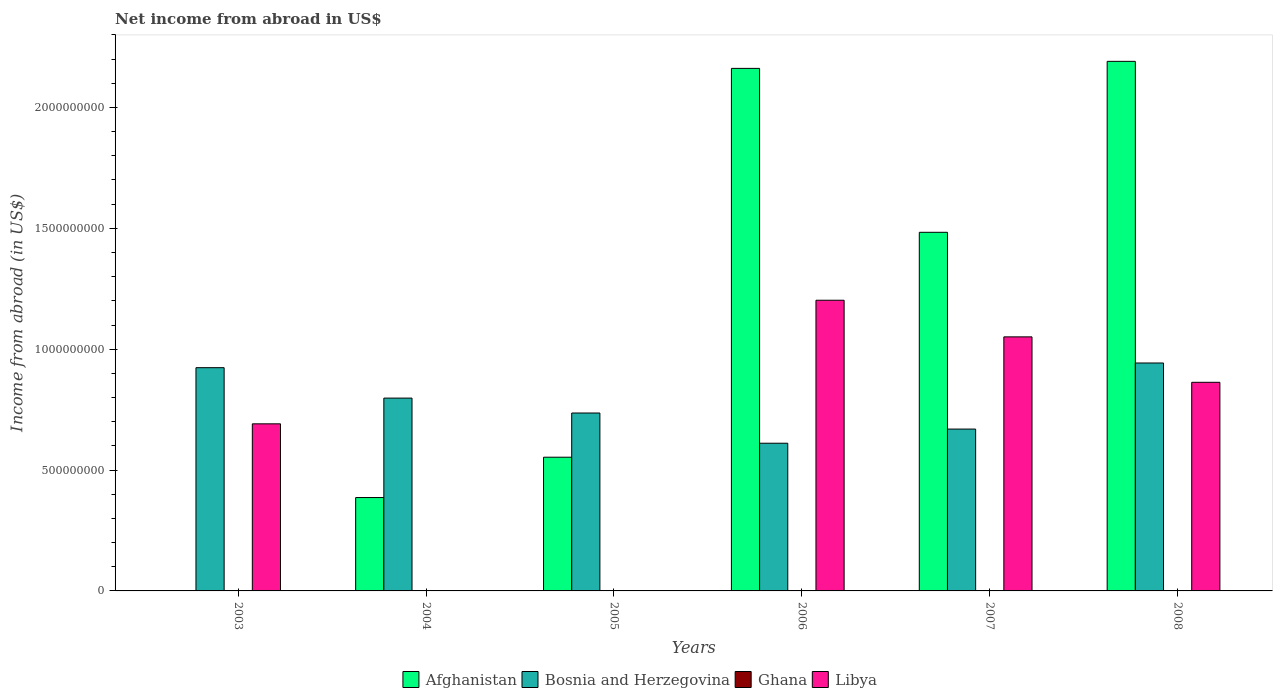What is the label of the 4th group of bars from the left?
Make the answer very short. 2006. What is the net income from abroad in Bosnia and Herzegovina in 2004?
Make the answer very short. 7.98e+08. Across all years, what is the maximum net income from abroad in Libya?
Your answer should be very brief. 1.20e+09. What is the difference between the net income from abroad in Afghanistan in 2004 and that in 2007?
Your answer should be very brief. -1.10e+09. What is the difference between the net income from abroad in Libya in 2006 and the net income from abroad in Bosnia and Herzegovina in 2004?
Offer a terse response. 4.05e+08. In the year 2008, what is the difference between the net income from abroad in Libya and net income from abroad in Afghanistan?
Your answer should be compact. -1.33e+09. What is the ratio of the net income from abroad in Afghanistan in 2005 to that in 2006?
Keep it short and to the point. 0.26. Is the net income from abroad in Afghanistan in 2006 less than that in 2008?
Your response must be concise. Yes. Is the difference between the net income from abroad in Libya in 2007 and 2008 greater than the difference between the net income from abroad in Afghanistan in 2007 and 2008?
Make the answer very short. Yes. What is the difference between the highest and the second highest net income from abroad in Libya?
Make the answer very short. 1.52e+08. What is the difference between the highest and the lowest net income from abroad in Libya?
Your answer should be very brief. 1.20e+09. Is it the case that in every year, the sum of the net income from abroad in Bosnia and Herzegovina and net income from abroad in Libya is greater than the net income from abroad in Ghana?
Offer a very short reply. Yes. Does the graph contain grids?
Your answer should be very brief. No. Where does the legend appear in the graph?
Offer a terse response. Bottom center. What is the title of the graph?
Your answer should be compact. Net income from abroad in US$. Does "Europe(developing only)" appear as one of the legend labels in the graph?
Offer a terse response. No. What is the label or title of the Y-axis?
Make the answer very short. Income from abroad (in US$). What is the Income from abroad (in US$) in Afghanistan in 2003?
Offer a terse response. 0. What is the Income from abroad (in US$) of Bosnia and Herzegovina in 2003?
Ensure brevity in your answer.  9.24e+08. What is the Income from abroad (in US$) in Ghana in 2003?
Your answer should be compact. 0. What is the Income from abroad (in US$) in Libya in 2003?
Keep it short and to the point. 6.91e+08. What is the Income from abroad (in US$) of Afghanistan in 2004?
Provide a succinct answer. 3.86e+08. What is the Income from abroad (in US$) of Bosnia and Herzegovina in 2004?
Your answer should be very brief. 7.98e+08. What is the Income from abroad (in US$) in Ghana in 2004?
Your answer should be compact. 0. What is the Income from abroad (in US$) in Libya in 2004?
Make the answer very short. 0. What is the Income from abroad (in US$) in Afghanistan in 2005?
Provide a short and direct response. 5.53e+08. What is the Income from abroad (in US$) in Bosnia and Herzegovina in 2005?
Ensure brevity in your answer.  7.36e+08. What is the Income from abroad (in US$) in Afghanistan in 2006?
Provide a succinct answer. 2.16e+09. What is the Income from abroad (in US$) in Bosnia and Herzegovina in 2006?
Your answer should be very brief. 6.11e+08. What is the Income from abroad (in US$) of Ghana in 2006?
Provide a short and direct response. 0. What is the Income from abroad (in US$) in Libya in 2006?
Your answer should be very brief. 1.20e+09. What is the Income from abroad (in US$) in Afghanistan in 2007?
Offer a very short reply. 1.48e+09. What is the Income from abroad (in US$) of Bosnia and Herzegovina in 2007?
Your answer should be very brief. 6.70e+08. What is the Income from abroad (in US$) of Ghana in 2007?
Offer a very short reply. 0. What is the Income from abroad (in US$) of Libya in 2007?
Your answer should be very brief. 1.05e+09. What is the Income from abroad (in US$) of Afghanistan in 2008?
Provide a short and direct response. 2.19e+09. What is the Income from abroad (in US$) of Bosnia and Herzegovina in 2008?
Provide a succinct answer. 9.43e+08. What is the Income from abroad (in US$) of Libya in 2008?
Make the answer very short. 8.63e+08. Across all years, what is the maximum Income from abroad (in US$) of Afghanistan?
Your answer should be compact. 2.19e+09. Across all years, what is the maximum Income from abroad (in US$) of Bosnia and Herzegovina?
Offer a very short reply. 9.43e+08. Across all years, what is the maximum Income from abroad (in US$) in Libya?
Provide a short and direct response. 1.20e+09. Across all years, what is the minimum Income from abroad (in US$) in Afghanistan?
Your answer should be very brief. 0. Across all years, what is the minimum Income from abroad (in US$) of Bosnia and Herzegovina?
Provide a succinct answer. 6.11e+08. What is the total Income from abroad (in US$) of Afghanistan in the graph?
Provide a short and direct response. 6.78e+09. What is the total Income from abroad (in US$) of Bosnia and Herzegovina in the graph?
Your answer should be compact. 4.68e+09. What is the total Income from abroad (in US$) in Ghana in the graph?
Provide a short and direct response. 0. What is the total Income from abroad (in US$) in Libya in the graph?
Your answer should be compact. 3.81e+09. What is the difference between the Income from abroad (in US$) in Bosnia and Herzegovina in 2003 and that in 2004?
Make the answer very short. 1.26e+08. What is the difference between the Income from abroad (in US$) in Bosnia and Herzegovina in 2003 and that in 2005?
Provide a succinct answer. 1.88e+08. What is the difference between the Income from abroad (in US$) of Bosnia and Herzegovina in 2003 and that in 2006?
Offer a very short reply. 3.13e+08. What is the difference between the Income from abroad (in US$) of Libya in 2003 and that in 2006?
Give a very brief answer. -5.11e+08. What is the difference between the Income from abroad (in US$) of Bosnia and Herzegovina in 2003 and that in 2007?
Give a very brief answer. 2.54e+08. What is the difference between the Income from abroad (in US$) in Libya in 2003 and that in 2007?
Make the answer very short. -3.60e+08. What is the difference between the Income from abroad (in US$) of Bosnia and Herzegovina in 2003 and that in 2008?
Offer a terse response. -1.94e+07. What is the difference between the Income from abroad (in US$) in Libya in 2003 and that in 2008?
Ensure brevity in your answer.  -1.72e+08. What is the difference between the Income from abroad (in US$) in Afghanistan in 2004 and that in 2005?
Your answer should be very brief. -1.67e+08. What is the difference between the Income from abroad (in US$) of Bosnia and Herzegovina in 2004 and that in 2005?
Offer a terse response. 6.17e+07. What is the difference between the Income from abroad (in US$) of Afghanistan in 2004 and that in 2006?
Make the answer very short. -1.78e+09. What is the difference between the Income from abroad (in US$) in Bosnia and Herzegovina in 2004 and that in 2006?
Give a very brief answer. 1.87e+08. What is the difference between the Income from abroad (in US$) in Afghanistan in 2004 and that in 2007?
Your answer should be compact. -1.10e+09. What is the difference between the Income from abroad (in US$) in Bosnia and Herzegovina in 2004 and that in 2007?
Provide a succinct answer. 1.28e+08. What is the difference between the Income from abroad (in US$) of Afghanistan in 2004 and that in 2008?
Give a very brief answer. -1.80e+09. What is the difference between the Income from abroad (in US$) in Bosnia and Herzegovina in 2004 and that in 2008?
Offer a terse response. -1.45e+08. What is the difference between the Income from abroad (in US$) in Afghanistan in 2005 and that in 2006?
Ensure brevity in your answer.  -1.61e+09. What is the difference between the Income from abroad (in US$) of Bosnia and Herzegovina in 2005 and that in 2006?
Your response must be concise. 1.25e+08. What is the difference between the Income from abroad (in US$) of Afghanistan in 2005 and that in 2007?
Your answer should be very brief. -9.30e+08. What is the difference between the Income from abroad (in US$) of Bosnia and Herzegovina in 2005 and that in 2007?
Your answer should be compact. 6.64e+07. What is the difference between the Income from abroad (in US$) of Afghanistan in 2005 and that in 2008?
Provide a short and direct response. -1.64e+09. What is the difference between the Income from abroad (in US$) in Bosnia and Herzegovina in 2005 and that in 2008?
Offer a very short reply. -2.07e+08. What is the difference between the Income from abroad (in US$) in Afghanistan in 2006 and that in 2007?
Keep it short and to the point. 6.78e+08. What is the difference between the Income from abroad (in US$) in Bosnia and Herzegovina in 2006 and that in 2007?
Offer a terse response. -5.86e+07. What is the difference between the Income from abroad (in US$) in Libya in 2006 and that in 2007?
Keep it short and to the point. 1.52e+08. What is the difference between the Income from abroad (in US$) in Afghanistan in 2006 and that in 2008?
Provide a succinct answer. -2.91e+07. What is the difference between the Income from abroad (in US$) of Bosnia and Herzegovina in 2006 and that in 2008?
Make the answer very short. -3.32e+08. What is the difference between the Income from abroad (in US$) in Libya in 2006 and that in 2008?
Your response must be concise. 3.40e+08. What is the difference between the Income from abroad (in US$) of Afghanistan in 2007 and that in 2008?
Offer a very short reply. -7.07e+08. What is the difference between the Income from abroad (in US$) in Bosnia and Herzegovina in 2007 and that in 2008?
Provide a short and direct response. -2.73e+08. What is the difference between the Income from abroad (in US$) of Libya in 2007 and that in 2008?
Provide a short and direct response. 1.88e+08. What is the difference between the Income from abroad (in US$) of Bosnia and Herzegovina in 2003 and the Income from abroad (in US$) of Libya in 2006?
Give a very brief answer. -2.79e+08. What is the difference between the Income from abroad (in US$) of Bosnia and Herzegovina in 2003 and the Income from abroad (in US$) of Libya in 2007?
Make the answer very short. -1.27e+08. What is the difference between the Income from abroad (in US$) of Bosnia and Herzegovina in 2003 and the Income from abroad (in US$) of Libya in 2008?
Offer a terse response. 6.05e+07. What is the difference between the Income from abroad (in US$) of Afghanistan in 2004 and the Income from abroad (in US$) of Bosnia and Herzegovina in 2005?
Provide a short and direct response. -3.50e+08. What is the difference between the Income from abroad (in US$) of Afghanistan in 2004 and the Income from abroad (in US$) of Bosnia and Herzegovina in 2006?
Give a very brief answer. -2.25e+08. What is the difference between the Income from abroad (in US$) of Afghanistan in 2004 and the Income from abroad (in US$) of Libya in 2006?
Your answer should be compact. -8.16e+08. What is the difference between the Income from abroad (in US$) in Bosnia and Herzegovina in 2004 and the Income from abroad (in US$) in Libya in 2006?
Keep it short and to the point. -4.05e+08. What is the difference between the Income from abroad (in US$) in Afghanistan in 2004 and the Income from abroad (in US$) in Bosnia and Herzegovina in 2007?
Offer a terse response. -2.83e+08. What is the difference between the Income from abroad (in US$) of Afghanistan in 2004 and the Income from abroad (in US$) of Libya in 2007?
Keep it short and to the point. -6.65e+08. What is the difference between the Income from abroad (in US$) in Bosnia and Herzegovina in 2004 and the Income from abroad (in US$) in Libya in 2007?
Keep it short and to the point. -2.53e+08. What is the difference between the Income from abroad (in US$) in Afghanistan in 2004 and the Income from abroad (in US$) in Bosnia and Herzegovina in 2008?
Make the answer very short. -5.57e+08. What is the difference between the Income from abroad (in US$) in Afghanistan in 2004 and the Income from abroad (in US$) in Libya in 2008?
Offer a very short reply. -4.77e+08. What is the difference between the Income from abroad (in US$) in Bosnia and Herzegovina in 2004 and the Income from abroad (in US$) in Libya in 2008?
Offer a terse response. -6.53e+07. What is the difference between the Income from abroad (in US$) of Afghanistan in 2005 and the Income from abroad (in US$) of Bosnia and Herzegovina in 2006?
Ensure brevity in your answer.  -5.79e+07. What is the difference between the Income from abroad (in US$) of Afghanistan in 2005 and the Income from abroad (in US$) of Libya in 2006?
Provide a short and direct response. -6.49e+08. What is the difference between the Income from abroad (in US$) of Bosnia and Herzegovina in 2005 and the Income from abroad (in US$) of Libya in 2006?
Ensure brevity in your answer.  -4.66e+08. What is the difference between the Income from abroad (in US$) in Afghanistan in 2005 and the Income from abroad (in US$) in Bosnia and Herzegovina in 2007?
Your answer should be compact. -1.16e+08. What is the difference between the Income from abroad (in US$) of Afghanistan in 2005 and the Income from abroad (in US$) of Libya in 2007?
Provide a succinct answer. -4.98e+08. What is the difference between the Income from abroad (in US$) in Bosnia and Herzegovina in 2005 and the Income from abroad (in US$) in Libya in 2007?
Give a very brief answer. -3.15e+08. What is the difference between the Income from abroad (in US$) in Afghanistan in 2005 and the Income from abroad (in US$) in Bosnia and Herzegovina in 2008?
Keep it short and to the point. -3.90e+08. What is the difference between the Income from abroad (in US$) of Afghanistan in 2005 and the Income from abroad (in US$) of Libya in 2008?
Provide a succinct answer. -3.10e+08. What is the difference between the Income from abroad (in US$) of Bosnia and Herzegovina in 2005 and the Income from abroad (in US$) of Libya in 2008?
Provide a short and direct response. -1.27e+08. What is the difference between the Income from abroad (in US$) of Afghanistan in 2006 and the Income from abroad (in US$) of Bosnia and Herzegovina in 2007?
Provide a short and direct response. 1.49e+09. What is the difference between the Income from abroad (in US$) of Afghanistan in 2006 and the Income from abroad (in US$) of Libya in 2007?
Keep it short and to the point. 1.11e+09. What is the difference between the Income from abroad (in US$) of Bosnia and Herzegovina in 2006 and the Income from abroad (in US$) of Libya in 2007?
Ensure brevity in your answer.  -4.40e+08. What is the difference between the Income from abroad (in US$) in Afghanistan in 2006 and the Income from abroad (in US$) in Bosnia and Herzegovina in 2008?
Offer a terse response. 1.22e+09. What is the difference between the Income from abroad (in US$) of Afghanistan in 2006 and the Income from abroad (in US$) of Libya in 2008?
Ensure brevity in your answer.  1.30e+09. What is the difference between the Income from abroad (in US$) in Bosnia and Herzegovina in 2006 and the Income from abroad (in US$) in Libya in 2008?
Offer a very short reply. -2.52e+08. What is the difference between the Income from abroad (in US$) in Afghanistan in 2007 and the Income from abroad (in US$) in Bosnia and Herzegovina in 2008?
Keep it short and to the point. 5.41e+08. What is the difference between the Income from abroad (in US$) of Afghanistan in 2007 and the Income from abroad (in US$) of Libya in 2008?
Give a very brief answer. 6.21e+08. What is the difference between the Income from abroad (in US$) in Bosnia and Herzegovina in 2007 and the Income from abroad (in US$) in Libya in 2008?
Provide a short and direct response. -1.93e+08. What is the average Income from abroad (in US$) in Afghanistan per year?
Give a very brief answer. 1.13e+09. What is the average Income from abroad (in US$) of Bosnia and Herzegovina per year?
Keep it short and to the point. 7.80e+08. What is the average Income from abroad (in US$) of Ghana per year?
Offer a terse response. 0. What is the average Income from abroad (in US$) in Libya per year?
Ensure brevity in your answer.  6.35e+08. In the year 2003, what is the difference between the Income from abroad (in US$) in Bosnia and Herzegovina and Income from abroad (in US$) in Libya?
Give a very brief answer. 2.32e+08. In the year 2004, what is the difference between the Income from abroad (in US$) of Afghanistan and Income from abroad (in US$) of Bosnia and Herzegovina?
Offer a very short reply. -4.11e+08. In the year 2005, what is the difference between the Income from abroad (in US$) in Afghanistan and Income from abroad (in US$) in Bosnia and Herzegovina?
Your answer should be compact. -1.83e+08. In the year 2006, what is the difference between the Income from abroad (in US$) of Afghanistan and Income from abroad (in US$) of Bosnia and Herzegovina?
Provide a succinct answer. 1.55e+09. In the year 2006, what is the difference between the Income from abroad (in US$) of Afghanistan and Income from abroad (in US$) of Libya?
Give a very brief answer. 9.59e+08. In the year 2006, what is the difference between the Income from abroad (in US$) in Bosnia and Herzegovina and Income from abroad (in US$) in Libya?
Make the answer very short. -5.92e+08. In the year 2007, what is the difference between the Income from abroad (in US$) of Afghanistan and Income from abroad (in US$) of Bosnia and Herzegovina?
Offer a terse response. 8.14e+08. In the year 2007, what is the difference between the Income from abroad (in US$) in Afghanistan and Income from abroad (in US$) in Libya?
Provide a succinct answer. 4.33e+08. In the year 2007, what is the difference between the Income from abroad (in US$) in Bosnia and Herzegovina and Income from abroad (in US$) in Libya?
Keep it short and to the point. -3.81e+08. In the year 2008, what is the difference between the Income from abroad (in US$) in Afghanistan and Income from abroad (in US$) in Bosnia and Herzegovina?
Give a very brief answer. 1.25e+09. In the year 2008, what is the difference between the Income from abroad (in US$) in Afghanistan and Income from abroad (in US$) in Libya?
Make the answer very short. 1.33e+09. In the year 2008, what is the difference between the Income from abroad (in US$) in Bosnia and Herzegovina and Income from abroad (in US$) in Libya?
Your answer should be compact. 7.99e+07. What is the ratio of the Income from abroad (in US$) of Bosnia and Herzegovina in 2003 to that in 2004?
Offer a terse response. 1.16. What is the ratio of the Income from abroad (in US$) of Bosnia and Herzegovina in 2003 to that in 2005?
Your answer should be compact. 1.25. What is the ratio of the Income from abroad (in US$) of Bosnia and Herzegovina in 2003 to that in 2006?
Provide a succinct answer. 1.51. What is the ratio of the Income from abroad (in US$) of Libya in 2003 to that in 2006?
Offer a very short reply. 0.57. What is the ratio of the Income from abroad (in US$) of Bosnia and Herzegovina in 2003 to that in 2007?
Offer a very short reply. 1.38. What is the ratio of the Income from abroad (in US$) of Libya in 2003 to that in 2007?
Offer a very short reply. 0.66. What is the ratio of the Income from abroad (in US$) of Bosnia and Herzegovina in 2003 to that in 2008?
Your answer should be very brief. 0.98. What is the ratio of the Income from abroad (in US$) in Libya in 2003 to that in 2008?
Ensure brevity in your answer.  0.8. What is the ratio of the Income from abroad (in US$) in Afghanistan in 2004 to that in 2005?
Provide a short and direct response. 0.7. What is the ratio of the Income from abroad (in US$) in Bosnia and Herzegovina in 2004 to that in 2005?
Make the answer very short. 1.08. What is the ratio of the Income from abroad (in US$) of Afghanistan in 2004 to that in 2006?
Ensure brevity in your answer.  0.18. What is the ratio of the Income from abroad (in US$) of Bosnia and Herzegovina in 2004 to that in 2006?
Give a very brief answer. 1.31. What is the ratio of the Income from abroad (in US$) of Afghanistan in 2004 to that in 2007?
Give a very brief answer. 0.26. What is the ratio of the Income from abroad (in US$) of Bosnia and Herzegovina in 2004 to that in 2007?
Your answer should be compact. 1.19. What is the ratio of the Income from abroad (in US$) of Afghanistan in 2004 to that in 2008?
Your answer should be very brief. 0.18. What is the ratio of the Income from abroad (in US$) in Bosnia and Herzegovina in 2004 to that in 2008?
Keep it short and to the point. 0.85. What is the ratio of the Income from abroad (in US$) in Afghanistan in 2005 to that in 2006?
Your response must be concise. 0.26. What is the ratio of the Income from abroad (in US$) of Bosnia and Herzegovina in 2005 to that in 2006?
Provide a succinct answer. 1.2. What is the ratio of the Income from abroad (in US$) of Afghanistan in 2005 to that in 2007?
Your answer should be compact. 0.37. What is the ratio of the Income from abroad (in US$) in Bosnia and Herzegovina in 2005 to that in 2007?
Your response must be concise. 1.1. What is the ratio of the Income from abroad (in US$) in Afghanistan in 2005 to that in 2008?
Offer a very short reply. 0.25. What is the ratio of the Income from abroad (in US$) in Bosnia and Herzegovina in 2005 to that in 2008?
Keep it short and to the point. 0.78. What is the ratio of the Income from abroad (in US$) of Afghanistan in 2006 to that in 2007?
Your response must be concise. 1.46. What is the ratio of the Income from abroad (in US$) of Bosnia and Herzegovina in 2006 to that in 2007?
Offer a terse response. 0.91. What is the ratio of the Income from abroad (in US$) in Libya in 2006 to that in 2007?
Give a very brief answer. 1.14. What is the ratio of the Income from abroad (in US$) of Afghanistan in 2006 to that in 2008?
Offer a very short reply. 0.99. What is the ratio of the Income from abroad (in US$) in Bosnia and Herzegovina in 2006 to that in 2008?
Offer a terse response. 0.65. What is the ratio of the Income from abroad (in US$) in Libya in 2006 to that in 2008?
Offer a very short reply. 1.39. What is the ratio of the Income from abroad (in US$) in Afghanistan in 2007 to that in 2008?
Offer a terse response. 0.68. What is the ratio of the Income from abroad (in US$) in Bosnia and Herzegovina in 2007 to that in 2008?
Your answer should be very brief. 0.71. What is the ratio of the Income from abroad (in US$) of Libya in 2007 to that in 2008?
Your answer should be very brief. 1.22. What is the difference between the highest and the second highest Income from abroad (in US$) in Afghanistan?
Your answer should be very brief. 2.91e+07. What is the difference between the highest and the second highest Income from abroad (in US$) in Bosnia and Herzegovina?
Provide a short and direct response. 1.94e+07. What is the difference between the highest and the second highest Income from abroad (in US$) of Libya?
Offer a terse response. 1.52e+08. What is the difference between the highest and the lowest Income from abroad (in US$) in Afghanistan?
Offer a very short reply. 2.19e+09. What is the difference between the highest and the lowest Income from abroad (in US$) of Bosnia and Herzegovina?
Ensure brevity in your answer.  3.32e+08. What is the difference between the highest and the lowest Income from abroad (in US$) of Libya?
Your answer should be compact. 1.20e+09. 